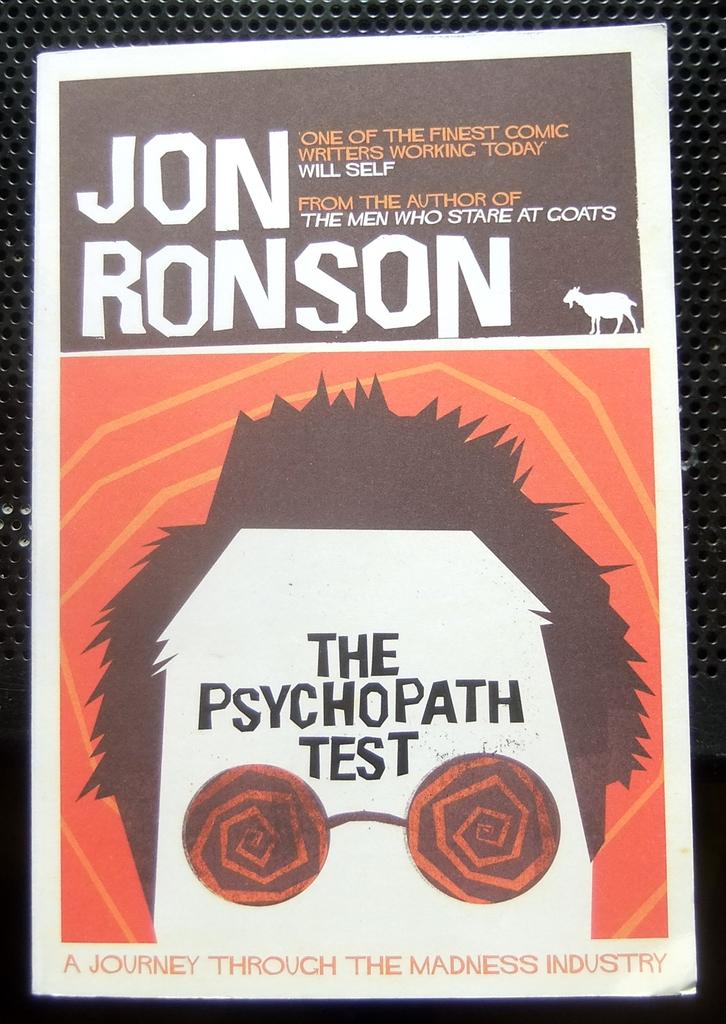What kind of test?
Your answer should be very brief. Psychopath. Who is the author of this book?
Make the answer very short. Jon ronson. 